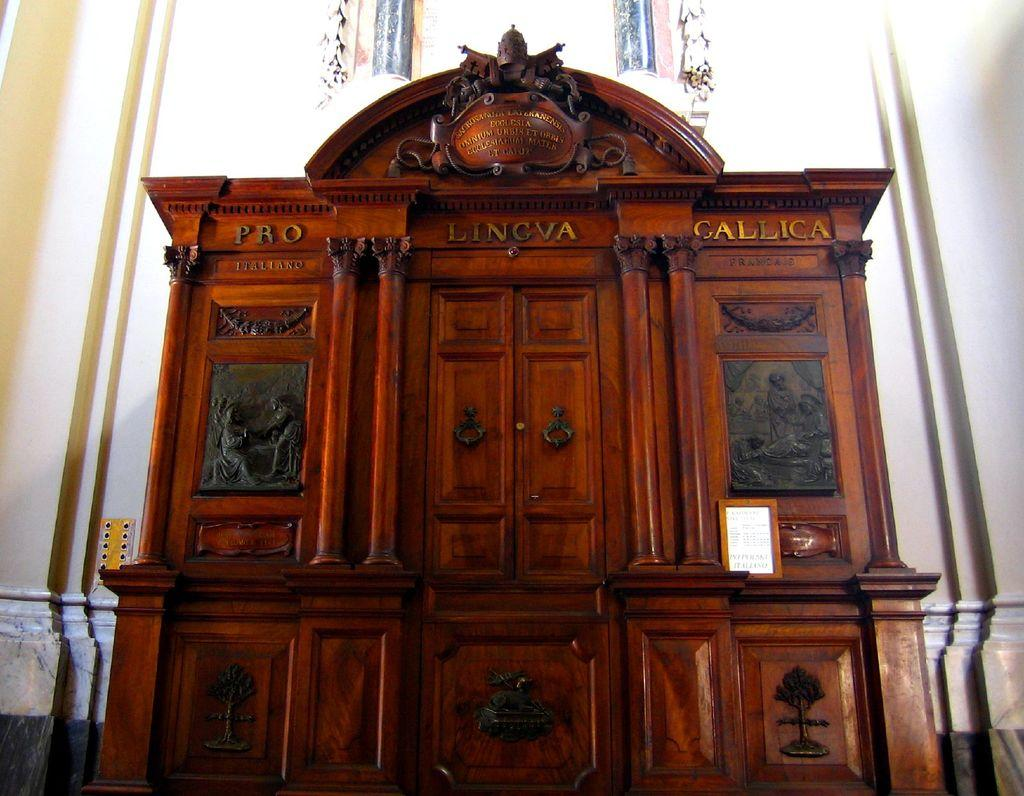What is located at the front of the image? There is a cupboard in the front of the image. What can be seen on the cupboard? There is text written on the cupboard. What is visible in the background of the image? There is a wall in the background of the image. What type of insurance does the expert recommend for the cast in the image? There is no cast or expert present in the image, so it is not possible to answer that question. 